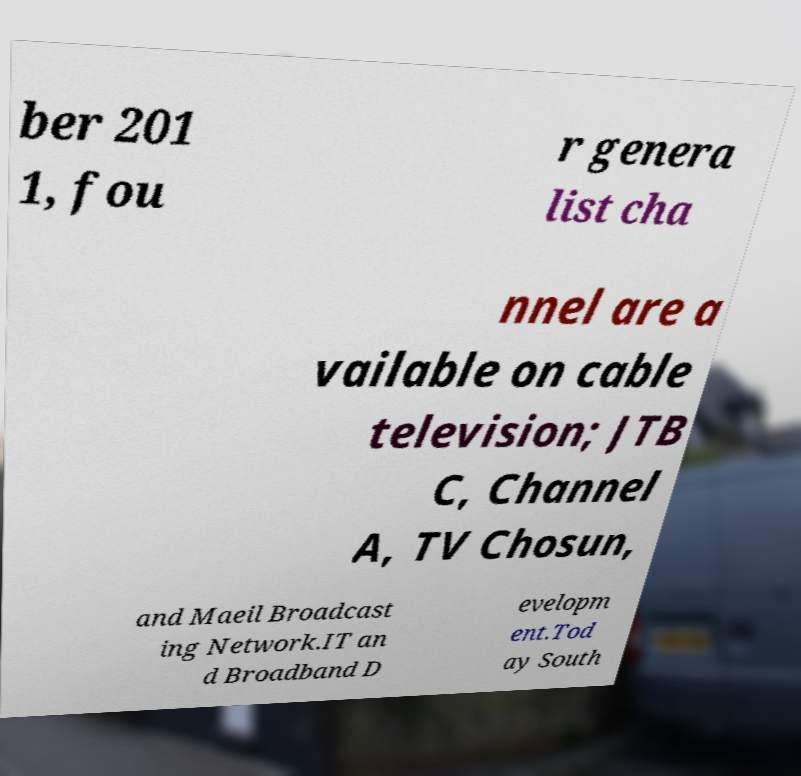For documentation purposes, I need the text within this image transcribed. Could you provide that? ber 201 1, fou r genera list cha nnel are a vailable on cable television; JTB C, Channel A, TV Chosun, and Maeil Broadcast ing Network.IT an d Broadband D evelopm ent.Tod ay South 